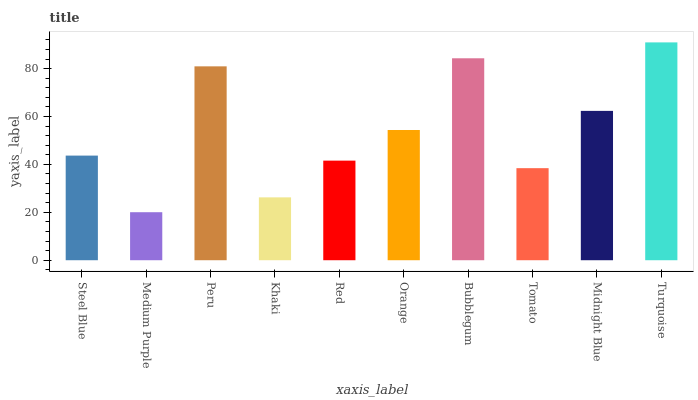Is Medium Purple the minimum?
Answer yes or no. Yes. Is Turquoise the maximum?
Answer yes or no. Yes. Is Peru the minimum?
Answer yes or no. No. Is Peru the maximum?
Answer yes or no. No. Is Peru greater than Medium Purple?
Answer yes or no. Yes. Is Medium Purple less than Peru?
Answer yes or no. Yes. Is Medium Purple greater than Peru?
Answer yes or no. No. Is Peru less than Medium Purple?
Answer yes or no. No. Is Orange the high median?
Answer yes or no. Yes. Is Steel Blue the low median?
Answer yes or no. Yes. Is Turquoise the high median?
Answer yes or no. No. Is Turquoise the low median?
Answer yes or no. No. 